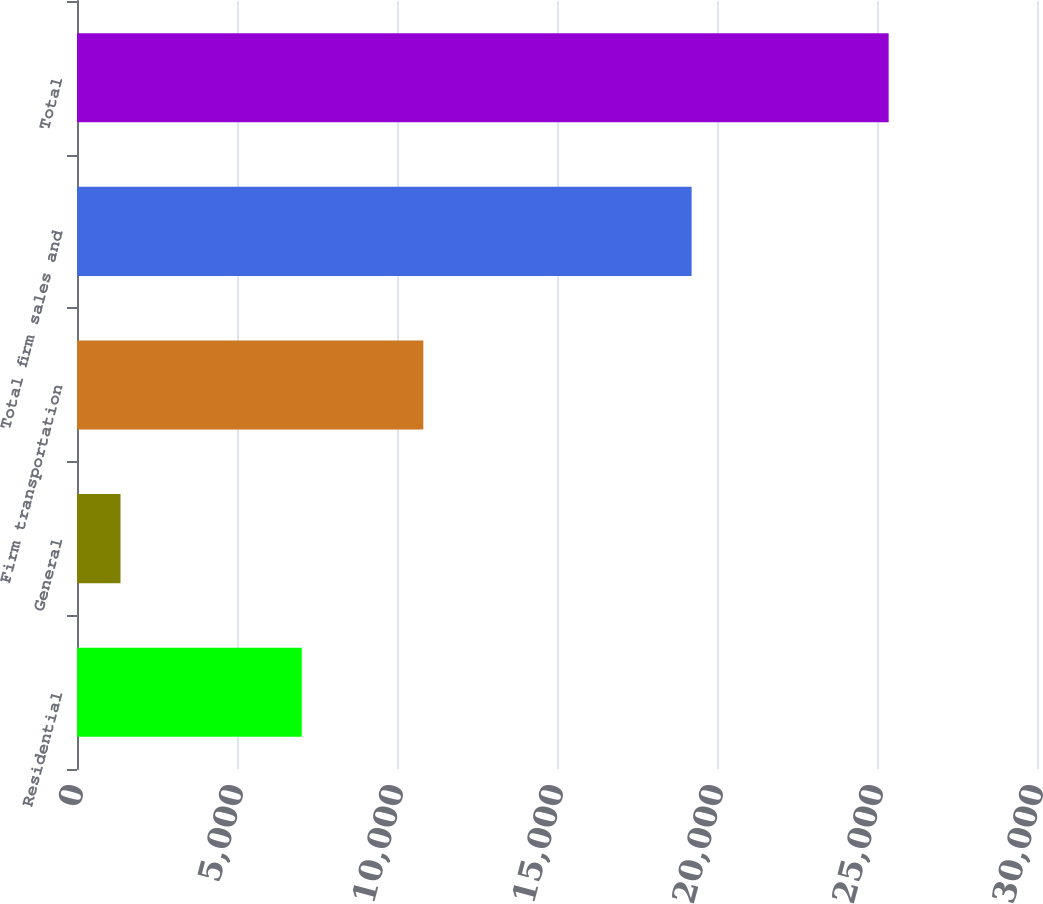Convert chart to OTSL. <chart><loc_0><loc_0><loc_500><loc_500><bar_chart><fcel>Residential<fcel>General<fcel>Firm transportation<fcel>Total firm sales and<fcel>Total<nl><fcel>7024<fcel>1360<fcel>10823<fcel>19207<fcel>25364<nl></chart> 